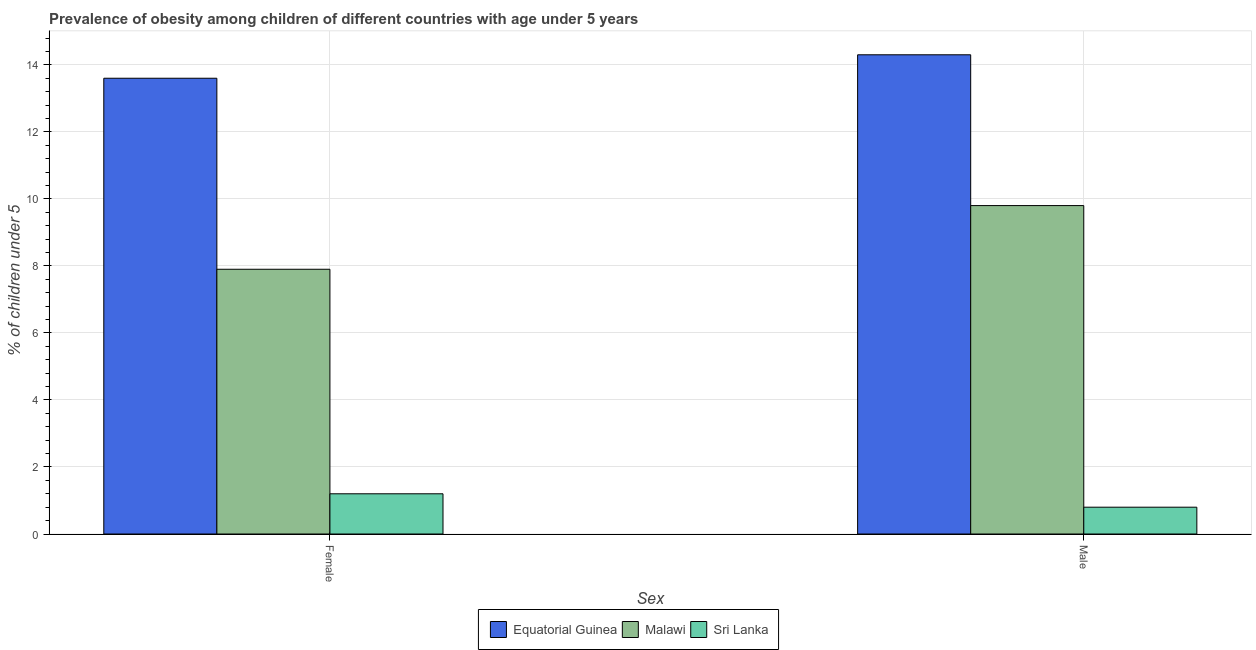How many different coloured bars are there?
Your response must be concise. 3. How many groups of bars are there?
Your response must be concise. 2. Are the number of bars per tick equal to the number of legend labels?
Ensure brevity in your answer.  Yes. How many bars are there on the 1st tick from the right?
Offer a terse response. 3. What is the label of the 1st group of bars from the left?
Make the answer very short. Female. What is the percentage of obese male children in Equatorial Guinea?
Your response must be concise. 14.3. Across all countries, what is the maximum percentage of obese male children?
Ensure brevity in your answer.  14.3. Across all countries, what is the minimum percentage of obese female children?
Give a very brief answer. 1.2. In which country was the percentage of obese male children maximum?
Make the answer very short. Equatorial Guinea. In which country was the percentage of obese female children minimum?
Keep it short and to the point. Sri Lanka. What is the total percentage of obese female children in the graph?
Ensure brevity in your answer.  22.7. What is the difference between the percentage of obese male children in Equatorial Guinea and that in Sri Lanka?
Give a very brief answer. 13.5. What is the difference between the percentage of obese female children in Sri Lanka and the percentage of obese male children in Equatorial Guinea?
Keep it short and to the point. -13.1. What is the average percentage of obese male children per country?
Ensure brevity in your answer.  8.3. What is the difference between the percentage of obese male children and percentage of obese female children in Sri Lanka?
Give a very brief answer. -0.4. In how many countries, is the percentage of obese female children greater than 6.8 %?
Offer a very short reply. 2. What is the ratio of the percentage of obese female children in Sri Lanka to that in Malawi?
Your response must be concise. 0.15. Is the percentage of obese female children in Sri Lanka less than that in Equatorial Guinea?
Make the answer very short. Yes. In how many countries, is the percentage of obese male children greater than the average percentage of obese male children taken over all countries?
Give a very brief answer. 2. What does the 2nd bar from the left in Male represents?
Ensure brevity in your answer.  Malawi. What does the 1st bar from the right in Male represents?
Give a very brief answer. Sri Lanka. How many bars are there?
Provide a short and direct response. 6. Are all the bars in the graph horizontal?
Make the answer very short. No. How many countries are there in the graph?
Offer a very short reply. 3. What is the difference between two consecutive major ticks on the Y-axis?
Your response must be concise. 2. Where does the legend appear in the graph?
Keep it short and to the point. Bottom center. How many legend labels are there?
Make the answer very short. 3. What is the title of the graph?
Offer a very short reply. Prevalence of obesity among children of different countries with age under 5 years. What is the label or title of the X-axis?
Keep it short and to the point. Sex. What is the label or title of the Y-axis?
Provide a succinct answer.  % of children under 5. What is the  % of children under 5 in Equatorial Guinea in Female?
Provide a succinct answer. 13.6. What is the  % of children under 5 of Malawi in Female?
Provide a succinct answer. 7.9. What is the  % of children under 5 of Sri Lanka in Female?
Your response must be concise. 1.2. What is the  % of children under 5 of Equatorial Guinea in Male?
Your answer should be compact. 14.3. What is the  % of children under 5 in Malawi in Male?
Offer a very short reply. 9.8. What is the  % of children under 5 of Sri Lanka in Male?
Make the answer very short. 0.8. Across all Sex, what is the maximum  % of children under 5 in Equatorial Guinea?
Keep it short and to the point. 14.3. Across all Sex, what is the maximum  % of children under 5 of Malawi?
Make the answer very short. 9.8. Across all Sex, what is the maximum  % of children under 5 in Sri Lanka?
Ensure brevity in your answer.  1.2. Across all Sex, what is the minimum  % of children under 5 in Equatorial Guinea?
Your answer should be compact. 13.6. Across all Sex, what is the minimum  % of children under 5 in Malawi?
Offer a terse response. 7.9. Across all Sex, what is the minimum  % of children under 5 of Sri Lanka?
Your response must be concise. 0.8. What is the total  % of children under 5 in Equatorial Guinea in the graph?
Your answer should be very brief. 27.9. What is the total  % of children under 5 of Malawi in the graph?
Provide a succinct answer. 17.7. What is the difference between the  % of children under 5 of Malawi in Female and that in Male?
Your answer should be compact. -1.9. What is the difference between the  % of children under 5 of Equatorial Guinea in Female and the  % of children under 5 of Sri Lanka in Male?
Offer a terse response. 12.8. What is the average  % of children under 5 of Equatorial Guinea per Sex?
Offer a terse response. 13.95. What is the average  % of children under 5 of Malawi per Sex?
Ensure brevity in your answer.  8.85. What is the difference between the  % of children under 5 in Equatorial Guinea and  % of children under 5 in Sri Lanka in Female?
Offer a very short reply. 12.4. What is the difference between the  % of children under 5 of Malawi and  % of children under 5 of Sri Lanka in Female?
Offer a terse response. 6.7. What is the difference between the  % of children under 5 in Malawi and  % of children under 5 in Sri Lanka in Male?
Make the answer very short. 9. What is the ratio of the  % of children under 5 of Equatorial Guinea in Female to that in Male?
Your answer should be compact. 0.95. What is the ratio of the  % of children under 5 of Malawi in Female to that in Male?
Ensure brevity in your answer.  0.81. What is the difference between the highest and the second highest  % of children under 5 of Malawi?
Keep it short and to the point. 1.9. What is the difference between the highest and the second highest  % of children under 5 in Sri Lanka?
Keep it short and to the point. 0.4. What is the difference between the highest and the lowest  % of children under 5 in Equatorial Guinea?
Your response must be concise. 0.7. What is the difference between the highest and the lowest  % of children under 5 of Sri Lanka?
Ensure brevity in your answer.  0.4. 